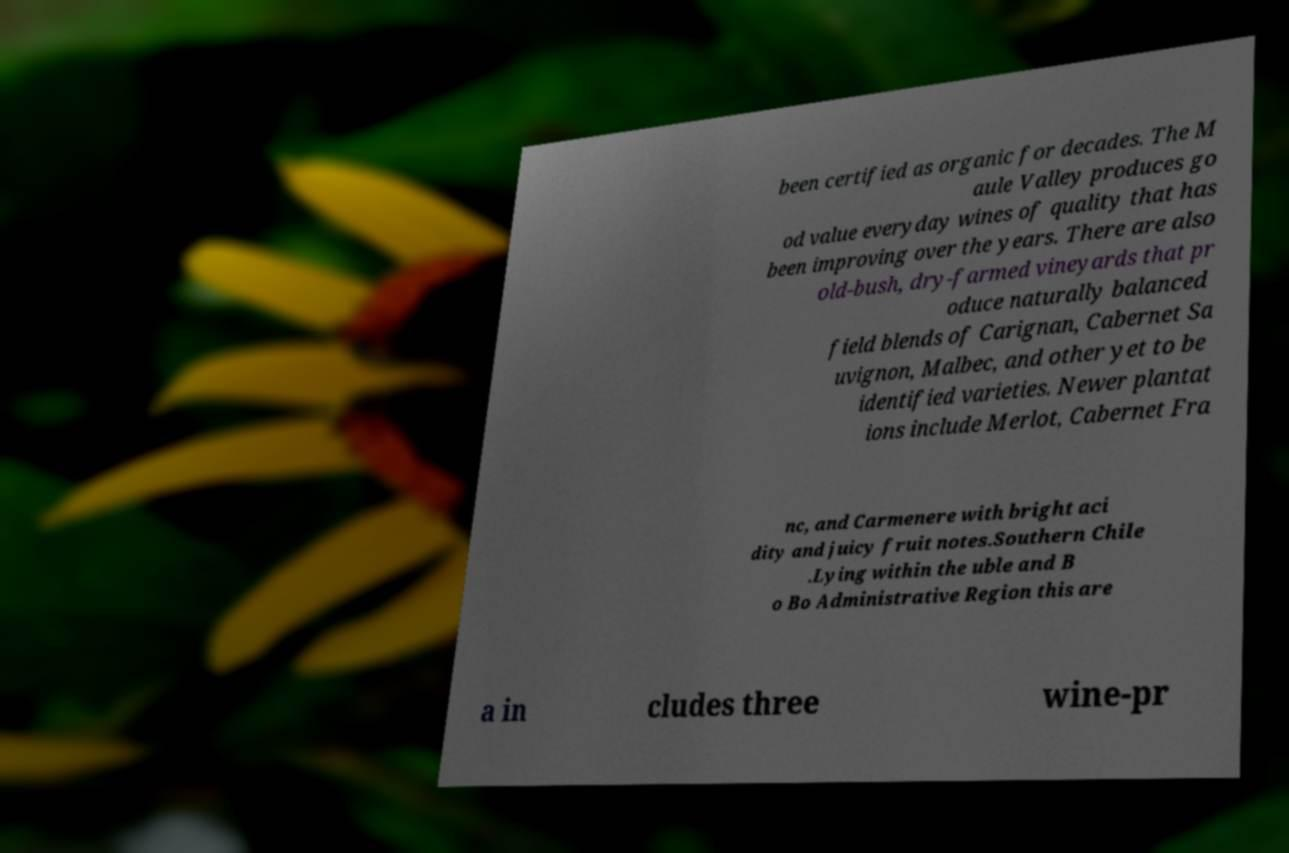Could you extract and type out the text from this image? been certified as organic for decades. The M aule Valley produces go od value everyday wines of quality that has been improving over the years. There are also old-bush, dry-farmed vineyards that pr oduce naturally balanced field blends of Carignan, Cabernet Sa uvignon, Malbec, and other yet to be identified varieties. Newer plantat ions include Merlot, Cabernet Fra nc, and Carmenere with bright aci dity and juicy fruit notes.Southern Chile .Lying within the uble and B o Bo Administrative Region this are a in cludes three wine-pr 